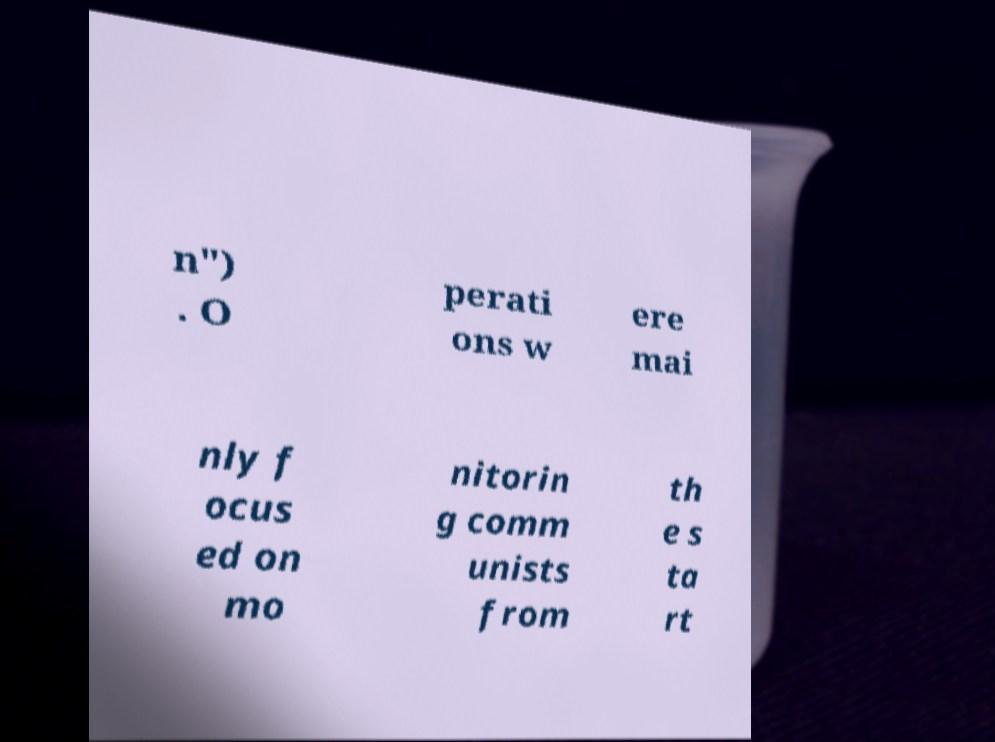Could you assist in decoding the text presented in this image and type it out clearly? n") . O perati ons w ere mai nly f ocus ed on mo nitorin g comm unists from th e s ta rt 